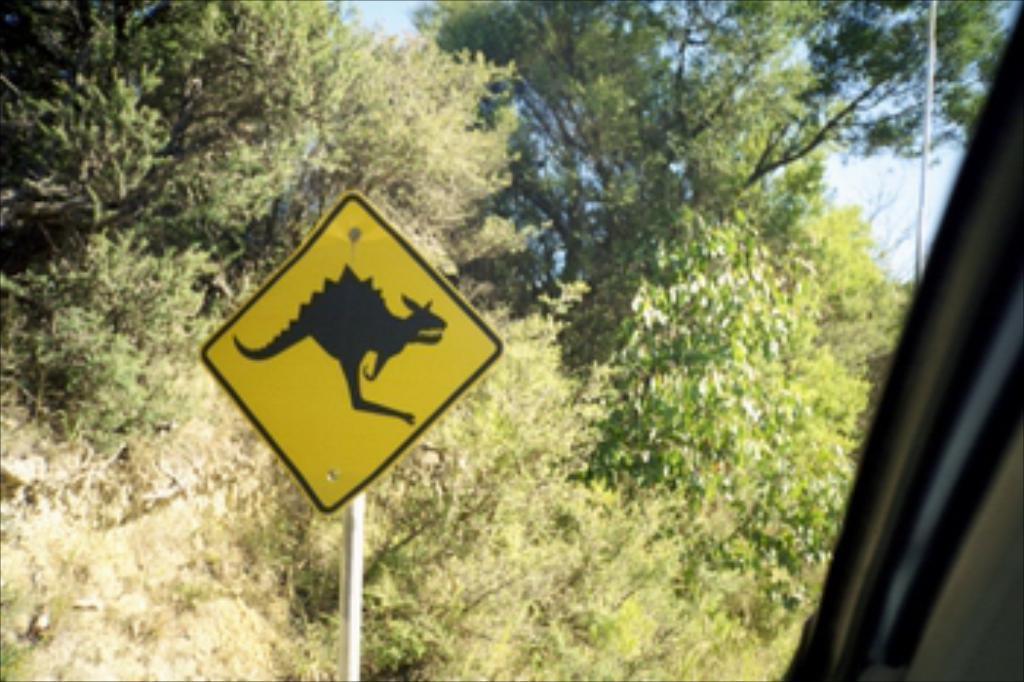Could you give a brief overview of what you see in this image? In this image I can see the yellow and black color board to the pole. To the side I can see the vehicle. In the background I can see many trees and the sky. 